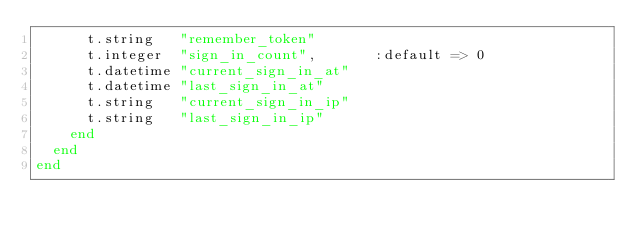<code> <loc_0><loc_0><loc_500><loc_500><_Ruby_>      t.string   "remember_token"
      t.integer  "sign_in_count",       :default => 0
      t.datetime "current_sign_in_at"
      t.datetime "last_sign_in_at"
      t.string   "current_sign_in_ip"
      t.string   "last_sign_in_ip"
    end
  end
end
</code> 